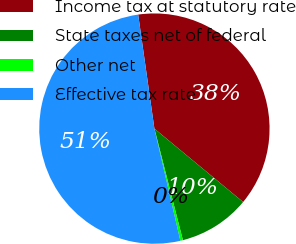Convert chart. <chart><loc_0><loc_0><loc_500><loc_500><pie_chart><fcel>Income tax at statutory rate<fcel>State taxes net of federal<fcel>Other net<fcel>Effective tax rate<nl><fcel>38.25%<fcel>10.02%<fcel>0.36%<fcel>51.37%<nl></chart> 